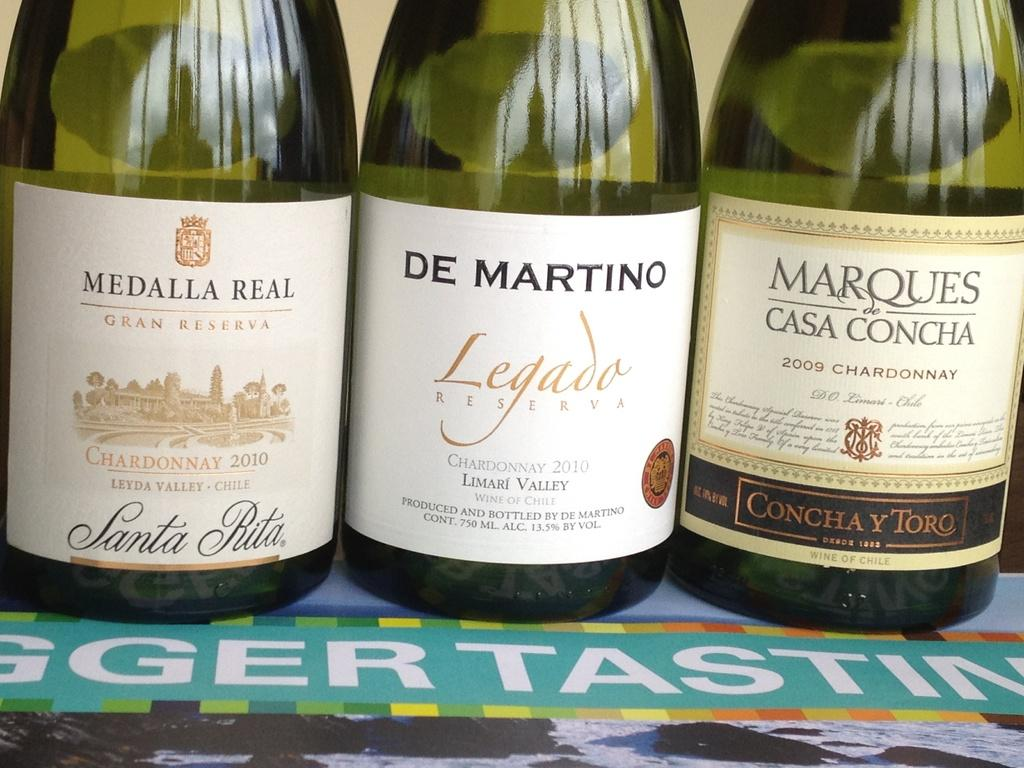Provide a one-sentence caption for the provided image. "DE MARTINO" is on one of three bottles. 